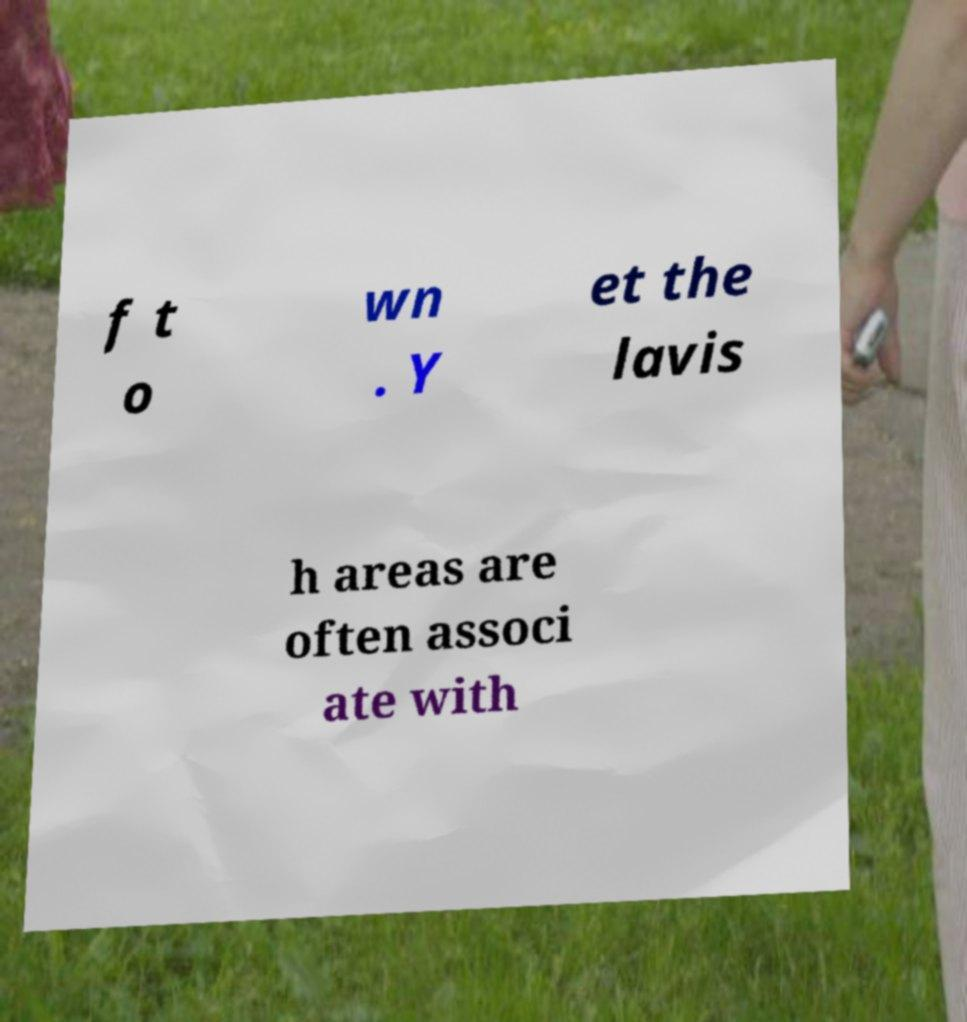Could you assist in decoding the text presented in this image and type it out clearly? f t o wn . Y et the lavis h areas are often associ ate with 